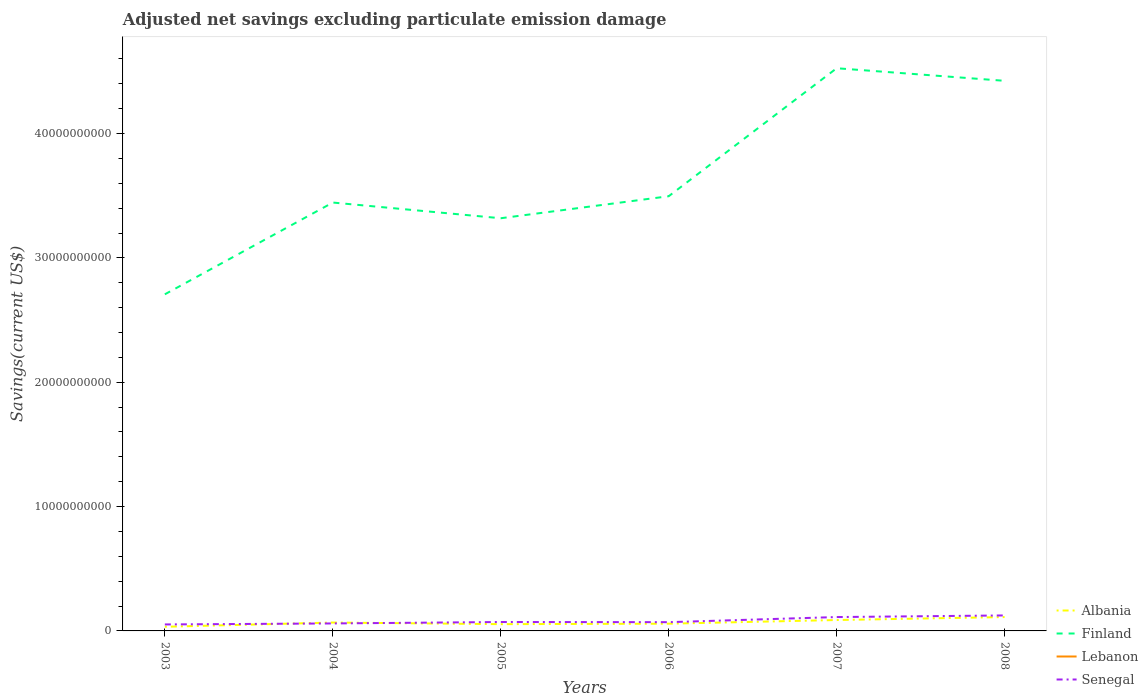Across all years, what is the maximum adjusted net savings in Albania?
Make the answer very short. 3.34e+08. What is the total adjusted net savings in Albania in the graph?
Your answer should be compact. -2.94e+08. What is the difference between the highest and the second highest adjusted net savings in Finland?
Ensure brevity in your answer.  1.82e+1. How many years are there in the graph?
Offer a terse response. 6. What is the difference between two consecutive major ticks on the Y-axis?
Provide a succinct answer. 1.00e+1. Does the graph contain grids?
Offer a terse response. No. Where does the legend appear in the graph?
Provide a succinct answer. Bottom right. How many legend labels are there?
Provide a short and direct response. 4. How are the legend labels stacked?
Make the answer very short. Vertical. What is the title of the graph?
Keep it short and to the point. Adjusted net savings excluding particulate emission damage. Does "Indonesia" appear as one of the legend labels in the graph?
Offer a terse response. No. What is the label or title of the X-axis?
Your response must be concise. Years. What is the label or title of the Y-axis?
Ensure brevity in your answer.  Savings(current US$). What is the Savings(current US$) of Albania in 2003?
Make the answer very short. 3.34e+08. What is the Savings(current US$) of Finland in 2003?
Your response must be concise. 2.71e+1. What is the Savings(current US$) of Senegal in 2003?
Offer a terse response. 5.21e+08. What is the Savings(current US$) in Albania in 2004?
Provide a succinct answer. 6.75e+08. What is the Savings(current US$) in Finland in 2004?
Ensure brevity in your answer.  3.44e+1. What is the Savings(current US$) of Lebanon in 2004?
Keep it short and to the point. 0. What is the Savings(current US$) in Senegal in 2004?
Your answer should be very brief. 6.01e+08. What is the Savings(current US$) of Albania in 2005?
Keep it short and to the point. 5.44e+08. What is the Savings(current US$) of Finland in 2005?
Provide a short and direct response. 3.32e+1. What is the Savings(current US$) of Senegal in 2005?
Ensure brevity in your answer.  7.17e+08. What is the Savings(current US$) in Albania in 2006?
Your response must be concise. 5.83e+08. What is the Savings(current US$) of Finland in 2006?
Provide a short and direct response. 3.50e+1. What is the Savings(current US$) of Lebanon in 2006?
Ensure brevity in your answer.  0. What is the Savings(current US$) in Senegal in 2006?
Offer a very short reply. 7.04e+08. What is the Savings(current US$) in Albania in 2007?
Offer a terse response. 8.76e+08. What is the Savings(current US$) of Finland in 2007?
Offer a very short reply. 4.53e+1. What is the Savings(current US$) of Senegal in 2007?
Provide a short and direct response. 1.12e+09. What is the Savings(current US$) of Albania in 2008?
Your response must be concise. 1.12e+09. What is the Savings(current US$) of Finland in 2008?
Give a very brief answer. 4.42e+1. What is the Savings(current US$) of Senegal in 2008?
Make the answer very short. 1.24e+09. Across all years, what is the maximum Savings(current US$) in Albania?
Provide a short and direct response. 1.12e+09. Across all years, what is the maximum Savings(current US$) in Finland?
Offer a very short reply. 4.53e+1. Across all years, what is the maximum Savings(current US$) of Senegal?
Keep it short and to the point. 1.24e+09. Across all years, what is the minimum Savings(current US$) in Albania?
Give a very brief answer. 3.34e+08. Across all years, what is the minimum Savings(current US$) of Finland?
Your answer should be very brief. 2.71e+1. Across all years, what is the minimum Savings(current US$) in Senegal?
Offer a terse response. 5.21e+08. What is the total Savings(current US$) of Albania in the graph?
Ensure brevity in your answer.  4.13e+09. What is the total Savings(current US$) of Finland in the graph?
Provide a short and direct response. 2.19e+11. What is the total Savings(current US$) of Lebanon in the graph?
Offer a very short reply. 0. What is the total Savings(current US$) in Senegal in the graph?
Provide a short and direct response. 4.90e+09. What is the difference between the Savings(current US$) in Albania in 2003 and that in 2004?
Your answer should be compact. -3.41e+08. What is the difference between the Savings(current US$) of Finland in 2003 and that in 2004?
Give a very brief answer. -7.38e+09. What is the difference between the Savings(current US$) in Senegal in 2003 and that in 2004?
Offer a terse response. -7.97e+07. What is the difference between the Savings(current US$) of Albania in 2003 and that in 2005?
Your response must be concise. -2.10e+08. What is the difference between the Savings(current US$) of Finland in 2003 and that in 2005?
Keep it short and to the point. -6.12e+09. What is the difference between the Savings(current US$) of Senegal in 2003 and that in 2005?
Provide a short and direct response. -1.95e+08. What is the difference between the Savings(current US$) of Albania in 2003 and that in 2006?
Offer a very short reply. -2.49e+08. What is the difference between the Savings(current US$) in Finland in 2003 and that in 2006?
Make the answer very short. -7.89e+09. What is the difference between the Savings(current US$) of Senegal in 2003 and that in 2006?
Offer a terse response. -1.82e+08. What is the difference between the Savings(current US$) of Albania in 2003 and that in 2007?
Your response must be concise. -5.42e+08. What is the difference between the Savings(current US$) of Finland in 2003 and that in 2007?
Your answer should be compact. -1.82e+1. What is the difference between the Savings(current US$) in Senegal in 2003 and that in 2007?
Your answer should be compact. -5.94e+08. What is the difference between the Savings(current US$) in Albania in 2003 and that in 2008?
Ensure brevity in your answer.  -7.81e+08. What is the difference between the Savings(current US$) in Finland in 2003 and that in 2008?
Offer a very short reply. -1.72e+1. What is the difference between the Savings(current US$) of Senegal in 2003 and that in 2008?
Your answer should be very brief. -7.23e+08. What is the difference between the Savings(current US$) of Albania in 2004 and that in 2005?
Your response must be concise. 1.31e+08. What is the difference between the Savings(current US$) in Finland in 2004 and that in 2005?
Offer a very short reply. 1.26e+09. What is the difference between the Savings(current US$) in Senegal in 2004 and that in 2005?
Your answer should be compact. -1.16e+08. What is the difference between the Savings(current US$) in Albania in 2004 and that in 2006?
Give a very brief answer. 9.27e+07. What is the difference between the Savings(current US$) of Finland in 2004 and that in 2006?
Offer a terse response. -5.07e+08. What is the difference between the Savings(current US$) in Senegal in 2004 and that in 2006?
Your answer should be very brief. -1.03e+08. What is the difference between the Savings(current US$) in Albania in 2004 and that in 2007?
Provide a succinct answer. -2.01e+08. What is the difference between the Savings(current US$) in Finland in 2004 and that in 2007?
Make the answer very short. -1.08e+1. What is the difference between the Savings(current US$) of Senegal in 2004 and that in 2007?
Keep it short and to the point. -5.14e+08. What is the difference between the Savings(current US$) in Albania in 2004 and that in 2008?
Offer a terse response. -4.40e+08. What is the difference between the Savings(current US$) of Finland in 2004 and that in 2008?
Your answer should be very brief. -9.79e+09. What is the difference between the Savings(current US$) in Senegal in 2004 and that in 2008?
Provide a succinct answer. -6.44e+08. What is the difference between the Savings(current US$) of Albania in 2005 and that in 2006?
Your answer should be very brief. -3.86e+07. What is the difference between the Savings(current US$) of Finland in 2005 and that in 2006?
Provide a succinct answer. -1.77e+09. What is the difference between the Savings(current US$) in Senegal in 2005 and that in 2006?
Keep it short and to the point. 1.30e+07. What is the difference between the Savings(current US$) in Albania in 2005 and that in 2007?
Offer a terse response. -3.32e+08. What is the difference between the Savings(current US$) of Finland in 2005 and that in 2007?
Make the answer very short. -1.21e+1. What is the difference between the Savings(current US$) of Senegal in 2005 and that in 2007?
Provide a succinct answer. -3.98e+08. What is the difference between the Savings(current US$) of Albania in 2005 and that in 2008?
Give a very brief answer. -5.71e+08. What is the difference between the Savings(current US$) in Finland in 2005 and that in 2008?
Your answer should be very brief. -1.11e+1. What is the difference between the Savings(current US$) in Senegal in 2005 and that in 2008?
Your answer should be very brief. -5.28e+08. What is the difference between the Savings(current US$) in Albania in 2006 and that in 2007?
Ensure brevity in your answer.  -2.94e+08. What is the difference between the Savings(current US$) in Finland in 2006 and that in 2007?
Provide a succinct answer. -1.03e+1. What is the difference between the Savings(current US$) in Senegal in 2006 and that in 2007?
Keep it short and to the point. -4.11e+08. What is the difference between the Savings(current US$) in Albania in 2006 and that in 2008?
Offer a very short reply. -5.32e+08. What is the difference between the Savings(current US$) of Finland in 2006 and that in 2008?
Your response must be concise. -9.28e+09. What is the difference between the Savings(current US$) of Senegal in 2006 and that in 2008?
Keep it short and to the point. -5.41e+08. What is the difference between the Savings(current US$) of Albania in 2007 and that in 2008?
Your answer should be compact. -2.39e+08. What is the difference between the Savings(current US$) of Finland in 2007 and that in 2008?
Provide a short and direct response. 1.01e+09. What is the difference between the Savings(current US$) in Senegal in 2007 and that in 2008?
Offer a very short reply. -1.30e+08. What is the difference between the Savings(current US$) of Albania in 2003 and the Savings(current US$) of Finland in 2004?
Your response must be concise. -3.41e+1. What is the difference between the Savings(current US$) of Albania in 2003 and the Savings(current US$) of Senegal in 2004?
Your answer should be compact. -2.67e+08. What is the difference between the Savings(current US$) of Finland in 2003 and the Savings(current US$) of Senegal in 2004?
Your answer should be very brief. 2.65e+1. What is the difference between the Savings(current US$) in Albania in 2003 and the Savings(current US$) in Finland in 2005?
Make the answer very short. -3.29e+1. What is the difference between the Savings(current US$) of Albania in 2003 and the Savings(current US$) of Senegal in 2005?
Your answer should be very brief. -3.83e+08. What is the difference between the Savings(current US$) in Finland in 2003 and the Savings(current US$) in Senegal in 2005?
Keep it short and to the point. 2.64e+1. What is the difference between the Savings(current US$) of Albania in 2003 and the Savings(current US$) of Finland in 2006?
Keep it short and to the point. -3.46e+1. What is the difference between the Savings(current US$) of Albania in 2003 and the Savings(current US$) of Senegal in 2006?
Provide a short and direct response. -3.70e+08. What is the difference between the Savings(current US$) of Finland in 2003 and the Savings(current US$) of Senegal in 2006?
Your response must be concise. 2.64e+1. What is the difference between the Savings(current US$) of Albania in 2003 and the Savings(current US$) of Finland in 2007?
Keep it short and to the point. -4.49e+1. What is the difference between the Savings(current US$) of Albania in 2003 and the Savings(current US$) of Senegal in 2007?
Give a very brief answer. -7.81e+08. What is the difference between the Savings(current US$) in Finland in 2003 and the Savings(current US$) in Senegal in 2007?
Keep it short and to the point. 2.60e+1. What is the difference between the Savings(current US$) in Albania in 2003 and the Savings(current US$) in Finland in 2008?
Your answer should be compact. -4.39e+1. What is the difference between the Savings(current US$) in Albania in 2003 and the Savings(current US$) in Senegal in 2008?
Provide a short and direct response. -9.11e+08. What is the difference between the Savings(current US$) in Finland in 2003 and the Savings(current US$) in Senegal in 2008?
Your answer should be compact. 2.58e+1. What is the difference between the Savings(current US$) in Albania in 2004 and the Savings(current US$) in Finland in 2005?
Ensure brevity in your answer.  -3.25e+1. What is the difference between the Savings(current US$) in Albania in 2004 and the Savings(current US$) in Senegal in 2005?
Your response must be concise. -4.15e+07. What is the difference between the Savings(current US$) of Finland in 2004 and the Savings(current US$) of Senegal in 2005?
Offer a very short reply. 3.37e+1. What is the difference between the Savings(current US$) of Albania in 2004 and the Savings(current US$) of Finland in 2006?
Give a very brief answer. -3.43e+1. What is the difference between the Savings(current US$) of Albania in 2004 and the Savings(current US$) of Senegal in 2006?
Your response must be concise. -2.85e+07. What is the difference between the Savings(current US$) in Finland in 2004 and the Savings(current US$) in Senegal in 2006?
Your answer should be compact. 3.37e+1. What is the difference between the Savings(current US$) in Albania in 2004 and the Savings(current US$) in Finland in 2007?
Your response must be concise. -4.46e+1. What is the difference between the Savings(current US$) in Albania in 2004 and the Savings(current US$) in Senegal in 2007?
Give a very brief answer. -4.40e+08. What is the difference between the Savings(current US$) of Finland in 2004 and the Savings(current US$) of Senegal in 2007?
Your response must be concise. 3.33e+1. What is the difference between the Savings(current US$) in Albania in 2004 and the Savings(current US$) in Finland in 2008?
Offer a terse response. -4.36e+1. What is the difference between the Savings(current US$) of Albania in 2004 and the Savings(current US$) of Senegal in 2008?
Keep it short and to the point. -5.70e+08. What is the difference between the Savings(current US$) in Finland in 2004 and the Savings(current US$) in Senegal in 2008?
Provide a short and direct response. 3.32e+1. What is the difference between the Savings(current US$) of Albania in 2005 and the Savings(current US$) of Finland in 2006?
Make the answer very short. -3.44e+1. What is the difference between the Savings(current US$) of Albania in 2005 and the Savings(current US$) of Senegal in 2006?
Your response must be concise. -1.60e+08. What is the difference between the Savings(current US$) of Finland in 2005 and the Savings(current US$) of Senegal in 2006?
Your response must be concise. 3.25e+1. What is the difference between the Savings(current US$) in Albania in 2005 and the Savings(current US$) in Finland in 2007?
Your answer should be compact. -4.47e+1. What is the difference between the Savings(current US$) in Albania in 2005 and the Savings(current US$) in Senegal in 2007?
Ensure brevity in your answer.  -5.71e+08. What is the difference between the Savings(current US$) of Finland in 2005 and the Savings(current US$) of Senegal in 2007?
Provide a short and direct response. 3.21e+1. What is the difference between the Savings(current US$) of Albania in 2005 and the Savings(current US$) of Finland in 2008?
Keep it short and to the point. -4.37e+1. What is the difference between the Savings(current US$) of Albania in 2005 and the Savings(current US$) of Senegal in 2008?
Keep it short and to the point. -7.01e+08. What is the difference between the Savings(current US$) of Finland in 2005 and the Savings(current US$) of Senegal in 2008?
Offer a terse response. 3.19e+1. What is the difference between the Savings(current US$) in Albania in 2006 and the Savings(current US$) in Finland in 2007?
Offer a terse response. -4.47e+1. What is the difference between the Savings(current US$) of Albania in 2006 and the Savings(current US$) of Senegal in 2007?
Offer a terse response. -5.33e+08. What is the difference between the Savings(current US$) in Finland in 2006 and the Savings(current US$) in Senegal in 2007?
Your answer should be compact. 3.38e+1. What is the difference between the Savings(current US$) in Albania in 2006 and the Savings(current US$) in Finland in 2008?
Provide a short and direct response. -4.37e+1. What is the difference between the Savings(current US$) of Albania in 2006 and the Savings(current US$) of Senegal in 2008?
Your answer should be compact. -6.62e+08. What is the difference between the Savings(current US$) in Finland in 2006 and the Savings(current US$) in Senegal in 2008?
Keep it short and to the point. 3.37e+1. What is the difference between the Savings(current US$) of Albania in 2007 and the Savings(current US$) of Finland in 2008?
Offer a very short reply. -4.34e+1. What is the difference between the Savings(current US$) in Albania in 2007 and the Savings(current US$) in Senegal in 2008?
Offer a very short reply. -3.68e+08. What is the difference between the Savings(current US$) in Finland in 2007 and the Savings(current US$) in Senegal in 2008?
Give a very brief answer. 4.40e+1. What is the average Savings(current US$) in Albania per year?
Provide a succinct answer. 6.88e+08. What is the average Savings(current US$) in Finland per year?
Your response must be concise. 3.65e+1. What is the average Savings(current US$) in Lebanon per year?
Your response must be concise. 0. What is the average Savings(current US$) in Senegal per year?
Your answer should be compact. 8.17e+08. In the year 2003, what is the difference between the Savings(current US$) in Albania and Savings(current US$) in Finland?
Give a very brief answer. -2.67e+1. In the year 2003, what is the difference between the Savings(current US$) of Albania and Savings(current US$) of Senegal?
Provide a short and direct response. -1.88e+08. In the year 2003, what is the difference between the Savings(current US$) in Finland and Savings(current US$) in Senegal?
Keep it short and to the point. 2.65e+1. In the year 2004, what is the difference between the Savings(current US$) in Albania and Savings(current US$) in Finland?
Offer a very short reply. -3.38e+1. In the year 2004, what is the difference between the Savings(current US$) of Albania and Savings(current US$) of Senegal?
Your answer should be compact. 7.41e+07. In the year 2004, what is the difference between the Savings(current US$) of Finland and Savings(current US$) of Senegal?
Your answer should be very brief. 3.38e+1. In the year 2005, what is the difference between the Savings(current US$) in Albania and Savings(current US$) in Finland?
Keep it short and to the point. -3.26e+1. In the year 2005, what is the difference between the Savings(current US$) of Albania and Savings(current US$) of Senegal?
Ensure brevity in your answer.  -1.73e+08. In the year 2005, what is the difference between the Savings(current US$) of Finland and Savings(current US$) of Senegal?
Keep it short and to the point. 3.25e+1. In the year 2006, what is the difference between the Savings(current US$) in Albania and Savings(current US$) in Finland?
Provide a short and direct response. -3.44e+1. In the year 2006, what is the difference between the Savings(current US$) in Albania and Savings(current US$) in Senegal?
Your response must be concise. -1.21e+08. In the year 2006, what is the difference between the Savings(current US$) of Finland and Savings(current US$) of Senegal?
Your response must be concise. 3.43e+1. In the year 2007, what is the difference between the Savings(current US$) in Albania and Savings(current US$) in Finland?
Provide a short and direct response. -4.44e+1. In the year 2007, what is the difference between the Savings(current US$) of Albania and Savings(current US$) of Senegal?
Provide a short and direct response. -2.39e+08. In the year 2007, what is the difference between the Savings(current US$) in Finland and Savings(current US$) in Senegal?
Offer a very short reply. 4.41e+1. In the year 2008, what is the difference between the Savings(current US$) of Albania and Savings(current US$) of Finland?
Ensure brevity in your answer.  -4.31e+1. In the year 2008, what is the difference between the Savings(current US$) of Albania and Savings(current US$) of Senegal?
Keep it short and to the point. -1.30e+08. In the year 2008, what is the difference between the Savings(current US$) in Finland and Savings(current US$) in Senegal?
Ensure brevity in your answer.  4.30e+1. What is the ratio of the Savings(current US$) in Albania in 2003 to that in 2004?
Your answer should be very brief. 0.49. What is the ratio of the Savings(current US$) of Finland in 2003 to that in 2004?
Keep it short and to the point. 0.79. What is the ratio of the Savings(current US$) in Senegal in 2003 to that in 2004?
Give a very brief answer. 0.87. What is the ratio of the Savings(current US$) in Albania in 2003 to that in 2005?
Your answer should be compact. 0.61. What is the ratio of the Savings(current US$) in Finland in 2003 to that in 2005?
Provide a succinct answer. 0.82. What is the ratio of the Savings(current US$) of Senegal in 2003 to that in 2005?
Keep it short and to the point. 0.73. What is the ratio of the Savings(current US$) in Albania in 2003 to that in 2006?
Ensure brevity in your answer.  0.57. What is the ratio of the Savings(current US$) in Finland in 2003 to that in 2006?
Provide a succinct answer. 0.77. What is the ratio of the Savings(current US$) in Senegal in 2003 to that in 2006?
Your answer should be very brief. 0.74. What is the ratio of the Savings(current US$) of Albania in 2003 to that in 2007?
Your answer should be very brief. 0.38. What is the ratio of the Savings(current US$) in Finland in 2003 to that in 2007?
Offer a very short reply. 0.6. What is the ratio of the Savings(current US$) in Senegal in 2003 to that in 2007?
Your answer should be very brief. 0.47. What is the ratio of the Savings(current US$) in Albania in 2003 to that in 2008?
Offer a very short reply. 0.3. What is the ratio of the Savings(current US$) in Finland in 2003 to that in 2008?
Your answer should be very brief. 0.61. What is the ratio of the Savings(current US$) in Senegal in 2003 to that in 2008?
Provide a succinct answer. 0.42. What is the ratio of the Savings(current US$) of Albania in 2004 to that in 2005?
Provide a short and direct response. 1.24. What is the ratio of the Savings(current US$) of Finland in 2004 to that in 2005?
Provide a short and direct response. 1.04. What is the ratio of the Savings(current US$) of Senegal in 2004 to that in 2005?
Your response must be concise. 0.84. What is the ratio of the Savings(current US$) in Albania in 2004 to that in 2006?
Your response must be concise. 1.16. What is the ratio of the Savings(current US$) in Finland in 2004 to that in 2006?
Keep it short and to the point. 0.99. What is the ratio of the Savings(current US$) of Senegal in 2004 to that in 2006?
Provide a succinct answer. 0.85. What is the ratio of the Savings(current US$) of Albania in 2004 to that in 2007?
Keep it short and to the point. 0.77. What is the ratio of the Savings(current US$) of Finland in 2004 to that in 2007?
Your response must be concise. 0.76. What is the ratio of the Savings(current US$) of Senegal in 2004 to that in 2007?
Make the answer very short. 0.54. What is the ratio of the Savings(current US$) of Albania in 2004 to that in 2008?
Your answer should be compact. 0.61. What is the ratio of the Savings(current US$) of Finland in 2004 to that in 2008?
Give a very brief answer. 0.78. What is the ratio of the Savings(current US$) of Senegal in 2004 to that in 2008?
Provide a succinct answer. 0.48. What is the ratio of the Savings(current US$) of Albania in 2005 to that in 2006?
Give a very brief answer. 0.93. What is the ratio of the Savings(current US$) of Finland in 2005 to that in 2006?
Provide a short and direct response. 0.95. What is the ratio of the Savings(current US$) in Senegal in 2005 to that in 2006?
Make the answer very short. 1.02. What is the ratio of the Savings(current US$) of Albania in 2005 to that in 2007?
Provide a succinct answer. 0.62. What is the ratio of the Savings(current US$) of Finland in 2005 to that in 2007?
Provide a succinct answer. 0.73. What is the ratio of the Savings(current US$) of Senegal in 2005 to that in 2007?
Offer a very short reply. 0.64. What is the ratio of the Savings(current US$) of Albania in 2005 to that in 2008?
Provide a succinct answer. 0.49. What is the ratio of the Savings(current US$) of Finland in 2005 to that in 2008?
Provide a short and direct response. 0.75. What is the ratio of the Savings(current US$) in Senegal in 2005 to that in 2008?
Offer a terse response. 0.58. What is the ratio of the Savings(current US$) in Albania in 2006 to that in 2007?
Your answer should be very brief. 0.66. What is the ratio of the Savings(current US$) of Finland in 2006 to that in 2007?
Your response must be concise. 0.77. What is the ratio of the Savings(current US$) in Senegal in 2006 to that in 2007?
Give a very brief answer. 0.63. What is the ratio of the Savings(current US$) in Albania in 2006 to that in 2008?
Provide a succinct answer. 0.52. What is the ratio of the Savings(current US$) of Finland in 2006 to that in 2008?
Provide a succinct answer. 0.79. What is the ratio of the Savings(current US$) of Senegal in 2006 to that in 2008?
Your answer should be very brief. 0.57. What is the ratio of the Savings(current US$) in Albania in 2007 to that in 2008?
Provide a succinct answer. 0.79. What is the ratio of the Savings(current US$) in Finland in 2007 to that in 2008?
Ensure brevity in your answer.  1.02. What is the ratio of the Savings(current US$) of Senegal in 2007 to that in 2008?
Ensure brevity in your answer.  0.9. What is the difference between the highest and the second highest Savings(current US$) in Albania?
Keep it short and to the point. 2.39e+08. What is the difference between the highest and the second highest Savings(current US$) in Finland?
Your answer should be compact. 1.01e+09. What is the difference between the highest and the second highest Savings(current US$) in Senegal?
Your answer should be very brief. 1.30e+08. What is the difference between the highest and the lowest Savings(current US$) in Albania?
Keep it short and to the point. 7.81e+08. What is the difference between the highest and the lowest Savings(current US$) of Finland?
Your response must be concise. 1.82e+1. What is the difference between the highest and the lowest Savings(current US$) in Senegal?
Ensure brevity in your answer.  7.23e+08. 